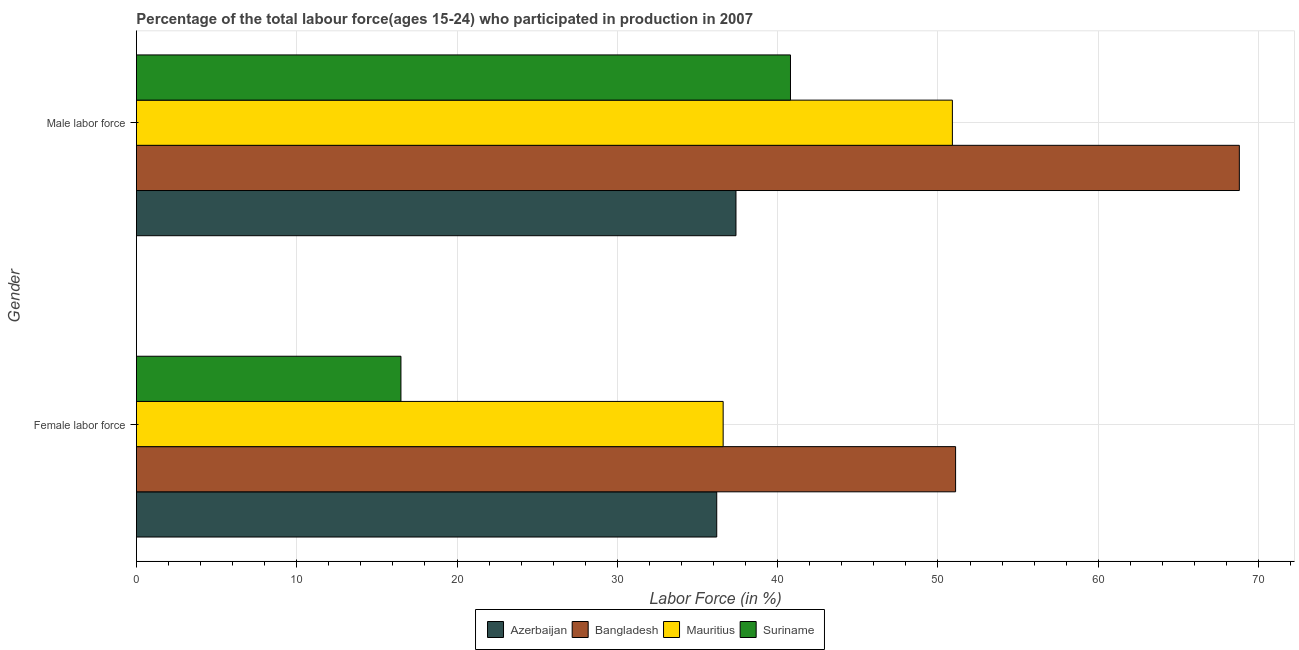How many different coloured bars are there?
Your response must be concise. 4. How many groups of bars are there?
Your answer should be compact. 2. How many bars are there on the 1st tick from the top?
Your answer should be compact. 4. How many bars are there on the 1st tick from the bottom?
Offer a very short reply. 4. What is the label of the 1st group of bars from the top?
Provide a short and direct response. Male labor force. What is the percentage of male labour force in Mauritius?
Your answer should be very brief. 50.9. Across all countries, what is the maximum percentage of male labour force?
Give a very brief answer. 68.8. Across all countries, what is the minimum percentage of male labour force?
Give a very brief answer. 37.4. In which country was the percentage of male labour force minimum?
Offer a terse response. Azerbaijan. What is the total percentage of male labour force in the graph?
Offer a very short reply. 197.9. What is the difference between the percentage of male labour force in Bangladesh and that in Suriname?
Offer a terse response. 28. What is the difference between the percentage of female labor force in Suriname and the percentage of male labour force in Azerbaijan?
Offer a very short reply. -20.9. What is the average percentage of female labor force per country?
Ensure brevity in your answer.  35.1. What is the difference between the percentage of male labour force and percentage of female labor force in Mauritius?
Offer a terse response. 14.3. In how many countries, is the percentage of female labor force greater than 44 %?
Offer a terse response. 1. What is the ratio of the percentage of female labor force in Mauritius to that in Suriname?
Offer a very short reply. 2.22. In how many countries, is the percentage of female labor force greater than the average percentage of female labor force taken over all countries?
Your answer should be compact. 3. What does the 1st bar from the top in Female labor force represents?
Provide a short and direct response. Suriname. What does the 2nd bar from the bottom in Male labor force represents?
Your response must be concise. Bangladesh. Are all the bars in the graph horizontal?
Your response must be concise. Yes. How many countries are there in the graph?
Your response must be concise. 4. What is the difference between two consecutive major ticks on the X-axis?
Provide a succinct answer. 10. Does the graph contain any zero values?
Ensure brevity in your answer.  No. What is the title of the graph?
Your response must be concise. Percentage of the total labour force(ages 15-24) who participated in production in 2007. What is the label or title of the X-axis?
Provide a succinct answer. Labor Force (in %). What is the label or title of the Y-axis?
Your response must be concise. Gender. What is the Labor Force (in %) of Azerbaijan in Female labor force?
Your answer should be compact. 36.2. What is the Labor Force (in %) in Bangladesh in Female labor force?
Provide a succinct answer. 51.1. What is the Labor Force (in %) in Mauritius in Female labor force?
Your response must be concise. 36.6. What is the Labor Force (in %) of Azerbaijan in Male labor force?
Your answer should be very brief. 37.4. What is the Labor Force (in %) in Bangladesh in Male labor force?
Ensure brevity in your answer.  68.8. What is the Labor Force (in %) in Mauritius in Male labor force?
Offer a terse response. 50.9. What is the Labor Force (in %) of Suriname in Male labor force?
Provide a succinct answer. 40.8. Across all Gender, what is the maximum Labor Force (in %) of Azerbaijan?
Your response must be concise. 37.4. Across all Gender, what is the maximum Labor Force (in %) of Bangladesh?
Ensure brevity in your answer.  68.8. Across all Gender, what is the maximum Labor Force (in %) of Mauritius?
Make the answer very short. 50.9. Across all Gender, what is the maximum Labor Force (in %) of Suriname?
Give a very brief answer. 40.8. Across all Gender, what is the minimum Labor Force (in %) of Azerbaijan?
Make the answer very short. 36.2. Across all Gender, what is the minimum Labor Force (in %) of Bangladesh?
Give a very brief answer. 51.1. Across all Gender, what is the minimum Labor Force (in %) in Mauritius?
Your answer should be very brief. 36.6. What is the total Labor Force (in %) of Azerbaijan in the graph?
Provide a succinct answer. 73.6. What is the total Labor Force (in %) of Bangladesh in the graph?
Your response must be concise. 119.9. What is the total Labor Force (in %) of Mauritius in the graph?
Provide a short and direct response. 87.5. What is the total Labor Force (in %) in Suriname in the graph?
Make the answer very short. 57.3. What is the difference between the Labor Force (in %) in Bangladesh in Female labor force and that in Male labor force?
Provide a succinct answer. -17.7. What is the difference between the Labor Force (in %) in Mauritius in Female labor force and that in Male labor force?
Give a very brief answer. -14.3. What is the difference between the Labor Force (in %) in Suriname in Female labor force and that in Male labor force?
Provide a short and direct response. -24.3. What is the difference between the Labor Force (in %) in Azerbaijan in Female labor force and the Labor Force (in %) in Bangladesh in Male labor force?
Keep it short and to the point. -32.6. What is the difference between the Labor Force (in %) of Azerbaijan in Female labor force and the Labor Force (in %) of Mauritius in Male labor force?
Keep it short and to the point. -14.7. What is the difference between the Labor Force (in %) in Azerbaijan in Female labor force and the Labor Force (in %) in Suriname in Male labor force?
Make the answer very short. -4.6. What is the difference between the Labor Force (in %) in Mauritius in Female labor force and the Labor Force (in %) in Suriname in Male labor force?
Offer a terse response. -4.2. What is the average Labor Force (in %) of Azerbaijan per Gender?
Ensure brevity in your answer.  36.8. What is the average Labor Force (in %) of Bangladesh per Gender?
Provide a succinct answer. 59.95. What is the average Labor Force (in %) in Mauritius per Gender?
Your answer should be very brief. 43.75. What is the average Labor Force (in %) in Suriname per Gender?
Ensure brevity in your answer.  28.65. What is the difference between the Labor Force (in %) in Azerbaijan and Labor Force (in %) in Bangladesh in Female labor force?
Make the answer very short. -14.9. What is the difference between the Labor Force (in %) in Azerbaijan and Labor Force (in %) in Suriname in Female labor force?
Provide a succinct answer. 19.7. What is the difference between the Labor Force (in %) in Bangladesh and Labor Force (in %) in Suriname in Female labor force?
Your answer should be compact. 34.6. What is the difference between the Labor Force (in %) in Mauritius and Labor Force (in %) in Suriname in Female labor force?
Your answer should be very brief. 20.1. What is the difference between the Labor Force (in %) in Azerbaijan and Labor Force (in %) in Bangladesh in Male labor force?
Offer a very short reply. -31.4. What is the difference between the Labor Force (in %) in Azerbaijan and Labor Force (in %) in Mauritius in Male labor force?
Ensure brevity in your answer.  -13.5. What is the difference between the Labor Force (in %) in Azerbaijan and Labor Force (in %) in Suriname in Male labor force?
Keep it short and to the point. -3.4. What is the difference between the Labor Force (in %) in Bangladesh and Labor Force (in %) in Mauritius in Male labor force?
Offer a very short reply. 17.9. What is the difference between the Labor Force (in %) of Mauritius and Labor Force (in %) of Suriname in Male labor force?
Keep it short and to the point. 10.1. What is the ratio of the Labor Force (in %) of Azerbaijan in Female labor force to that in Male labor force?
Your response must be concise. 0.97. What is the ratio of the Labor Force (in %) in Bangladesh in Female labor force to that in Male labor force?
Offer a terse response. 0.74. What is the ratio of the Labor Force (in %) of Mauritius in Female labor force to that in Male labor force?
Provide a short and direct response. 0.72. What is the ratio of the Labor Force (in %) of Suriname in Female labor force to that in Male labor force?
Give a very brief answer. 0.4. What is the difference between the highest and the second highest Labor Force (in %) of Bangladesh?
Your response must be concise. 17.7. What is the difference between the highest and the second highest Labor Force (in %) of Suriname?
Offer a very short reply. 24.3. What is the difference between the highest and the lowest Labor Force (in %) of Bangladesh?
Offer a very short reply. 17.7. What is the difference between the highest and the lowest Labor Force (in %) in Mauritius?
Give a very brief answer. 14.3. What is the difference between the highest and the lowest Labor Force (in %) in Suriname?
Provide a short and direct response. 24.3. 